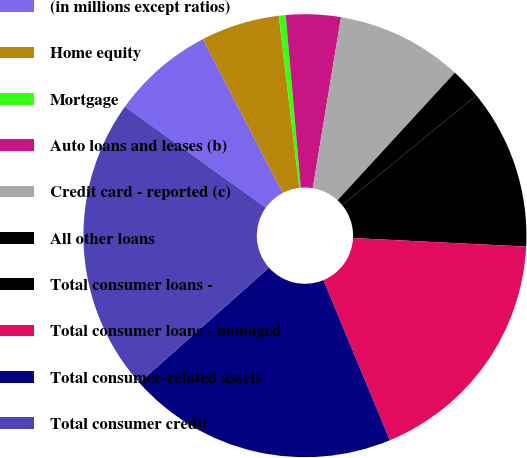Convert chart to OTSL. <chart><loc_0><loc_0><loc_500><loc_500><pie_chart><fcel>(in millions except ratios)<fcel>Home equity<fcel>Mortgage<fcel>Auto loans and leases (b)<fcel>Credit card - reported (c)<fcel>All other loans<fcel>Total consumer loans -<fcel>Total consumer loans - managed<fcel>Total consumer-related assets<fcel>Total consumer credit<nl><fcel>7.48%<fcel>5.74%<fcel>0.5%<fcel>3.99%<fcel>9.23%<fcel>2.24%<fcel>11.71%<fcel>17.96%<fcel>19.7%<fcel>21.45%<nl></chart> 